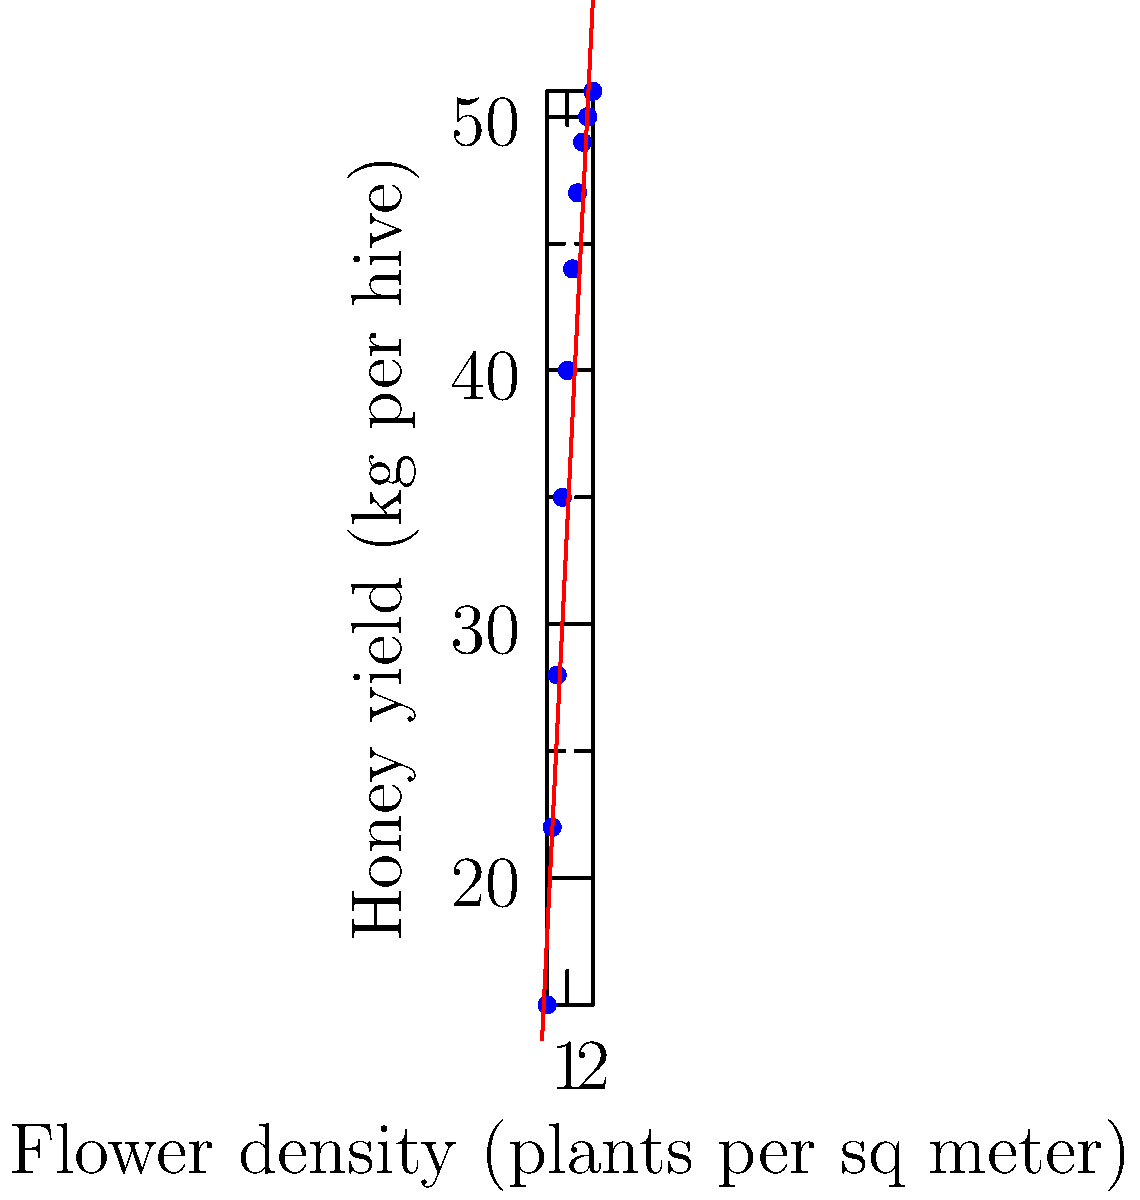Based on the scatter plot showing the relationship between flower density and honey yield, estimate the total honey yield for 100 hives if the surrounding area has a flower density of 1.5 plants per square meter. To solve this problem, we'll follow these steps:

1. Analyze the scatter plot to understand the relationship between flower density and honey yield.

2. Identify the best-fit line equation, which appears to be:
   $y = 20.45x + 13.64$
   where $y$ is the honey yield in kg per hive, and $x$ is the flower density in plants per square meter.

3. Calculate the estimated honey yield for a flower density of 1.5 plants/m²:
   $y = 20.45 \times 1.5 + 13.64$
   $y = 30.675 + 13.64$
   $y = 44.315$ kg per hive

4. Round the result to the nearest whole number:
   $44.315 \approx 44$ kg per hive

5. Calculate the total honey yield for 100 hives:
   $44 \text{ kg/hive} \times 100 \text{ hives} = 4,400 \text{ kg}$

Therefore, the estimated total honey yield for 100 hives with a surrounding flower density of 1.5 plants per square meter is 4,400 kg.
Answer: 4,400 kg 